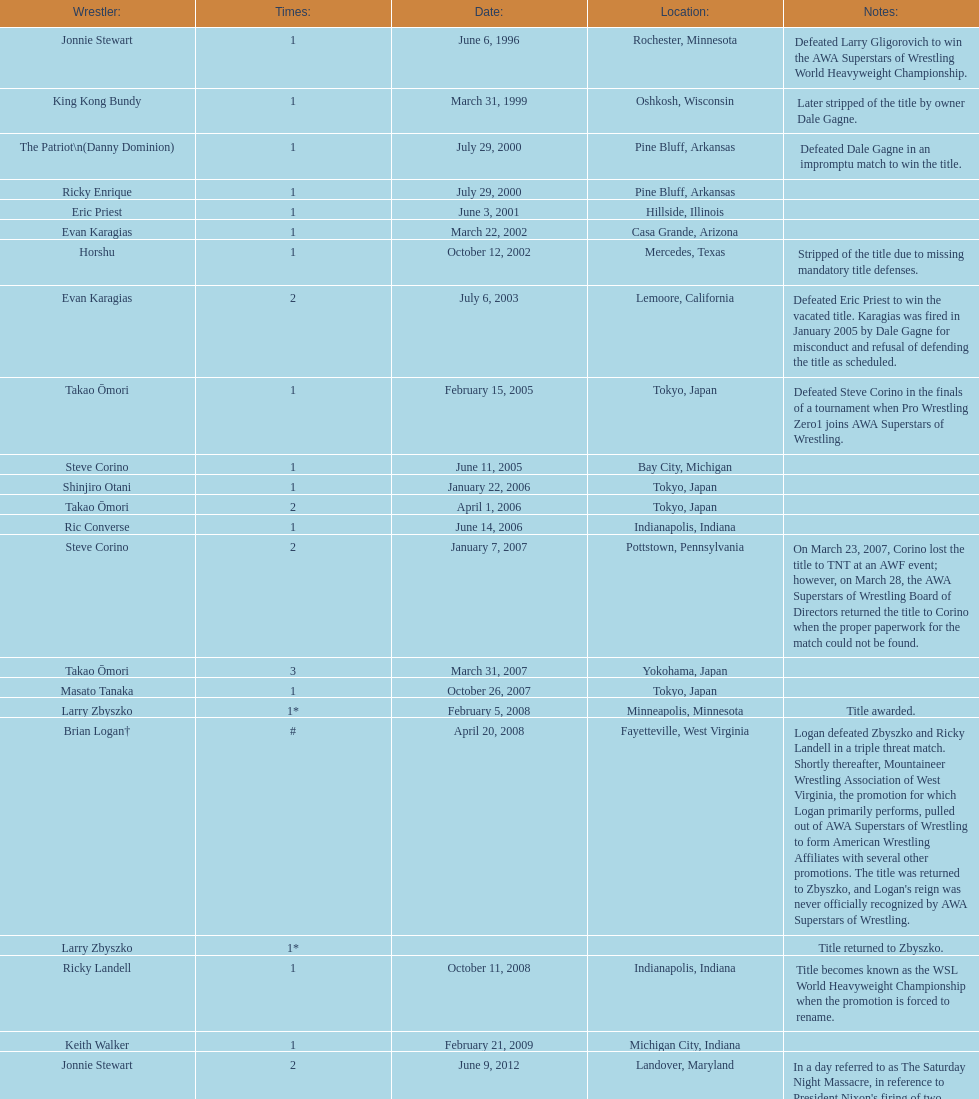What are the number of matches that happened in japan? 5. 